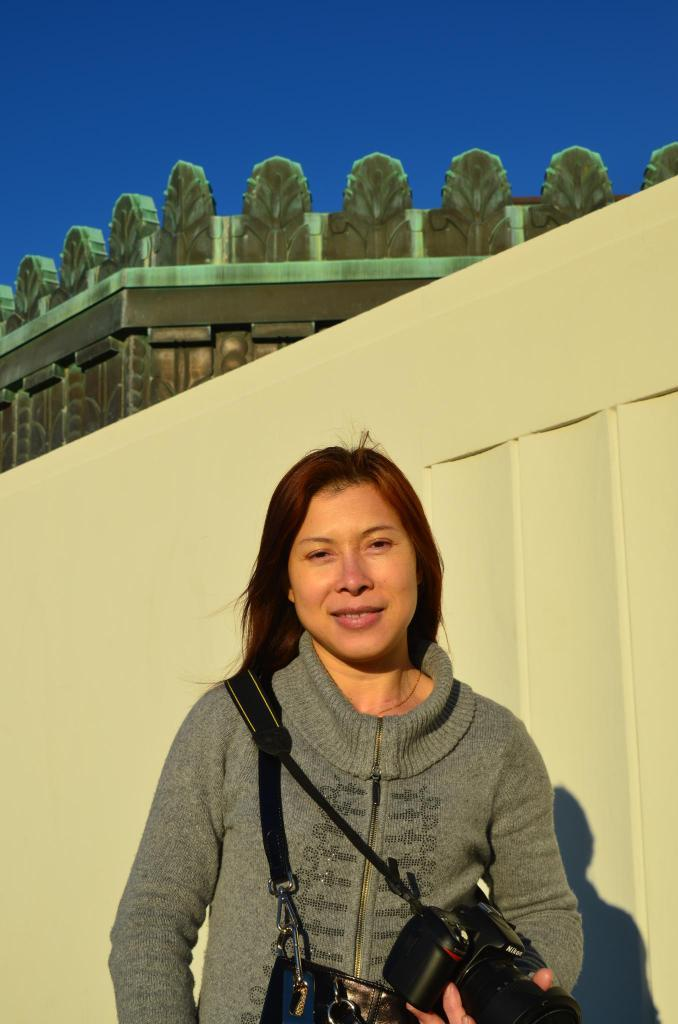Who is present in the image? There is a woman in the image. What is the woman doing in the image? The woman is smiling in the image. What objects is the woman holding? The woman is holding a bag and a camera in the image. What can be seen in the background of the image? There is a wall, a building, and the sky visible in the background of the image. How many clocks are hanging on the wall in the image? There are no clocks visible on the wall in the image. What type of connection is the woman making with the camera in the image? The image does not show the woman making any specific connection with the camera; she is simply holding it. 